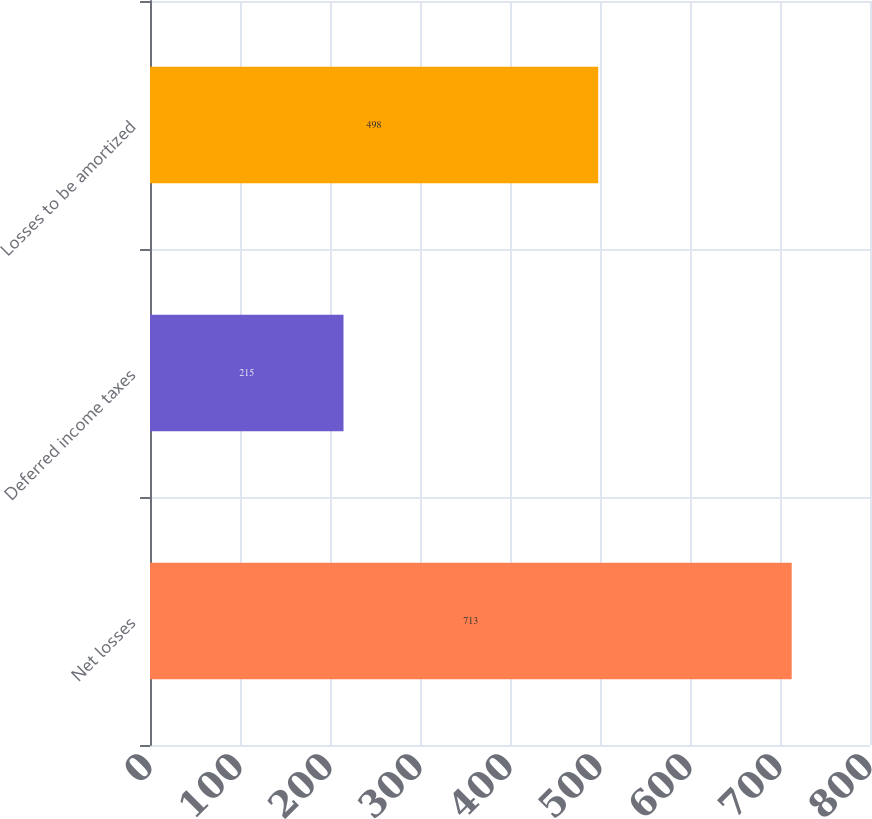<chart> <loc_0><loc_0><loc_500><loc_500><bar_chart><fcel>Net losses<fcel>Deferred income taxes<fcel>Losses to be amortized<nl><fcel>713<fcel>215<fcel>498<nl></chart> 